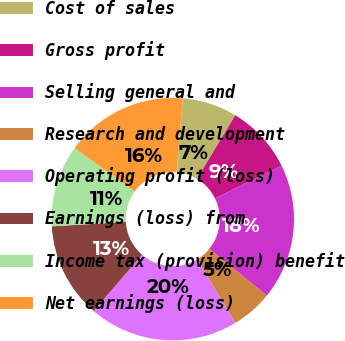Convert chart. <chart><loc_0><loc_0><loc_500><loc_500><pie_chart><fcel>Cost of sales<fcel>Gross profit<fcel>Selling general and<fcel>Research and development<fcel>Operating profit (loss)<fcel>Earnings (loss) from<fcel>Income tax (provision) benefit<fcel>Net earnings (loss)<nl><fcel>7.3%<fcel>9.11%<fcel>18.15%<fcel>5.49%<fcel>19.96%<fcel>12.73%<fcel>10.92%<fcel>16.34%<nl></chart> 